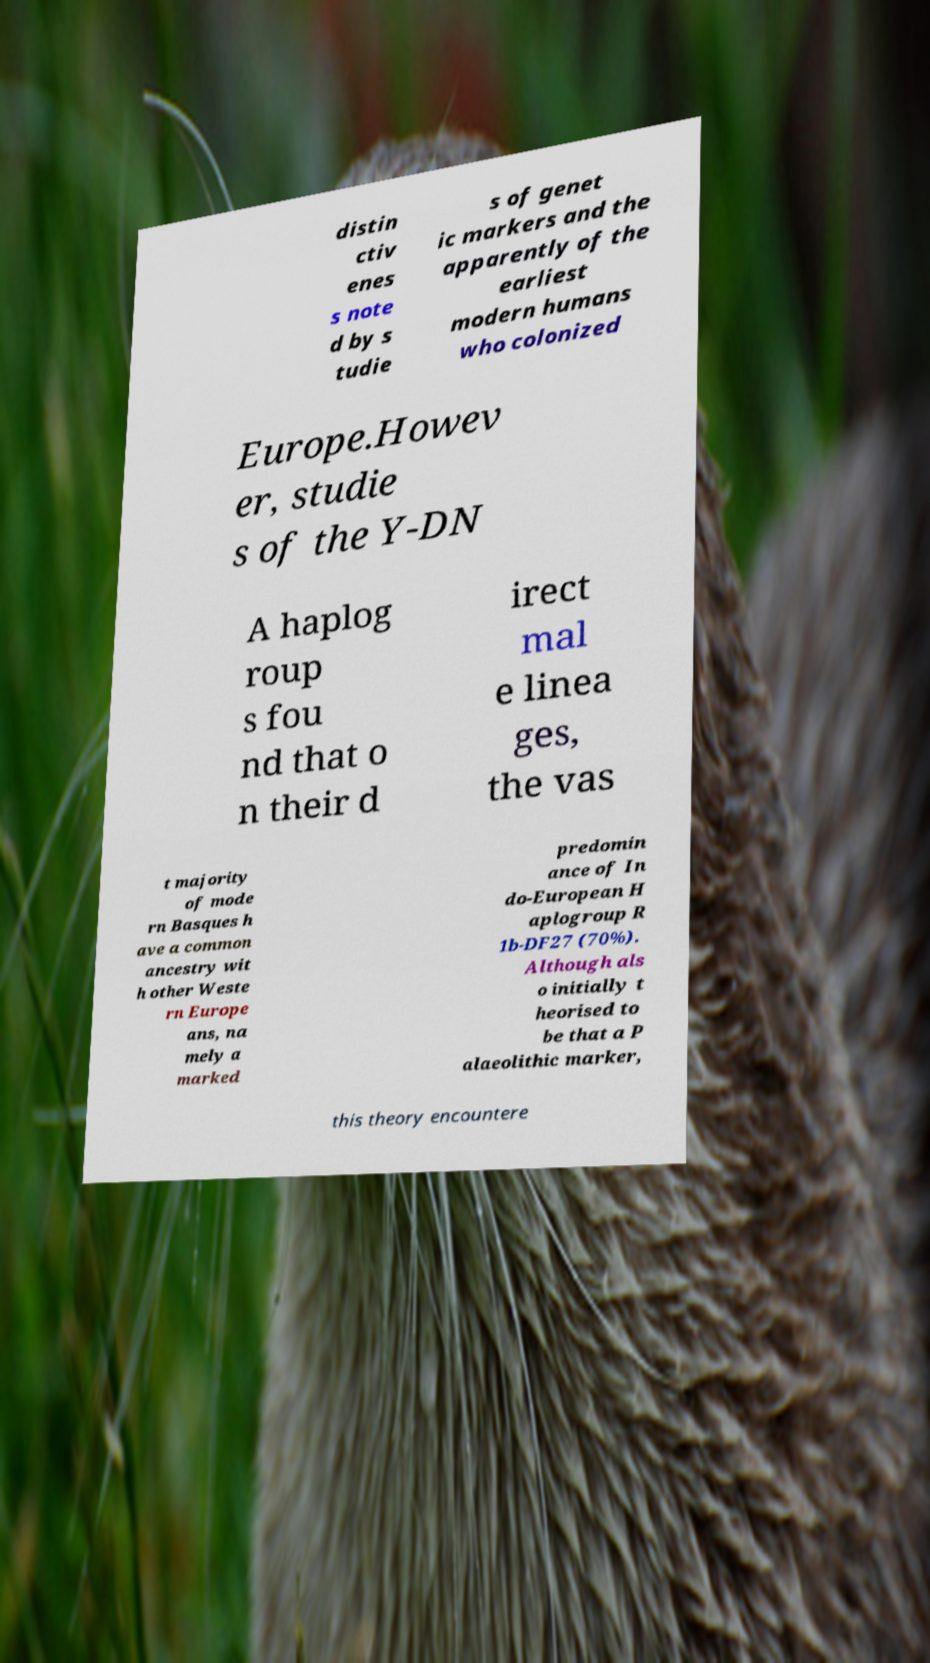Can you read and provide the text displayed in the image?This photo seems to have some interesting text. Can you extract and type it out for me? distin ctiv enes s note d by s tudie s of genet ic markers and the apparently of the earliest modern humans who colonized Europe.Howev er, studie s of the Y-DN A haplog roup s fou nd that o n their d irect mal e linea ges, the vas t majority of mode rn Basques h ave a common ancestry wit h other Weste rn Europe ans, na mely a marked predomin ance of In do-European H aplogroup R 1b-DF27 (70%). Although als o initially t heorised to be that a P alaeolithic marker, this theory encountere 